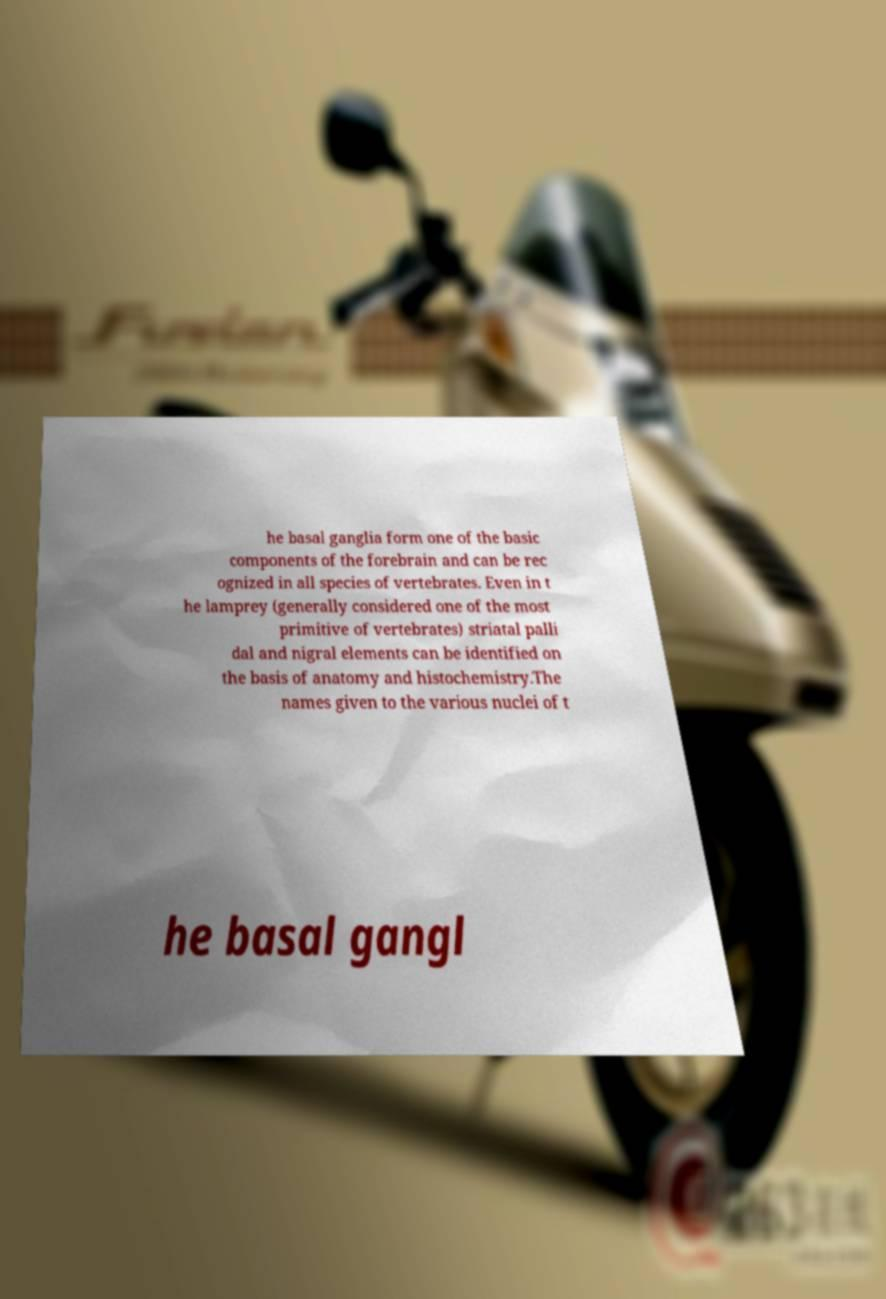Could you extract and type out the text from this image? he basal ganglia form one of the basic components of the forebrain and can be rec ognized in all species of vertebrates. Even in t he lamprey (generally considered one of the most primitive of vertebrates) striatal palli dal and nigral elements can be identified on the basis of anatomy and histochemistry.The names given to the various nuclei of t he basal gangl 